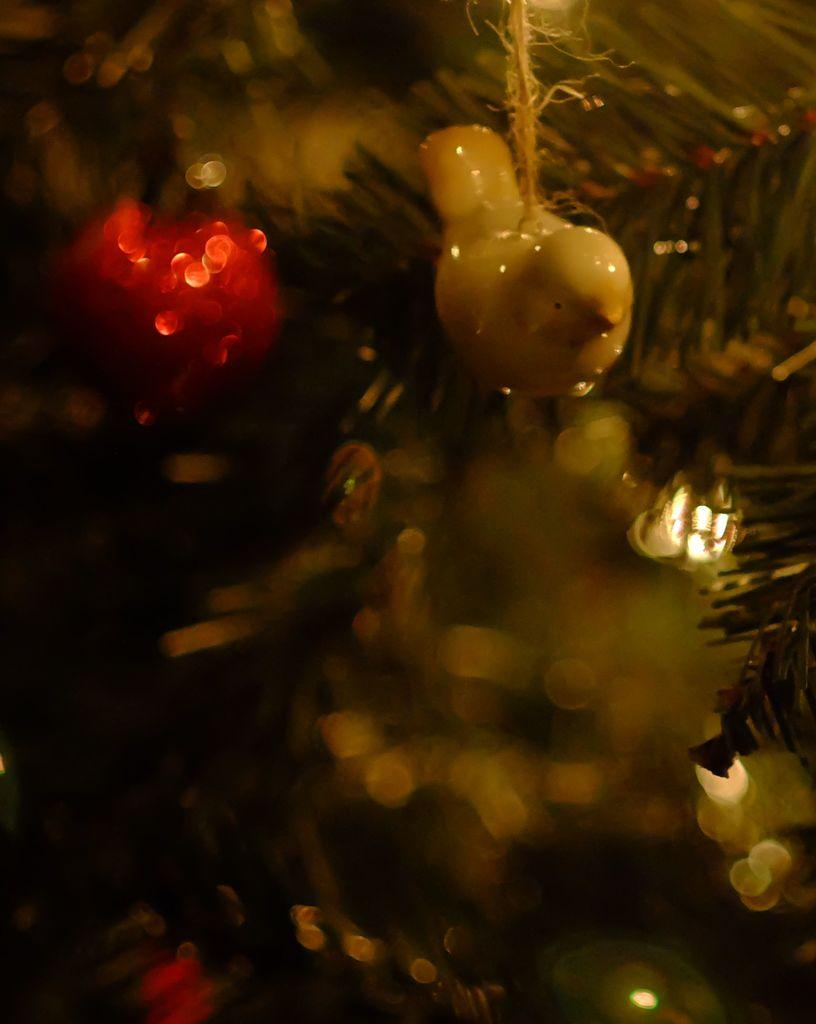What object can be seen in the image? There is a toy in the image. Can you describe the background of the image? The background of the image is blurred. What type of pickle is being used to pull the toy in the image? There is no pickle or pulling action present in the image; it only features a toy and a blurred background. 